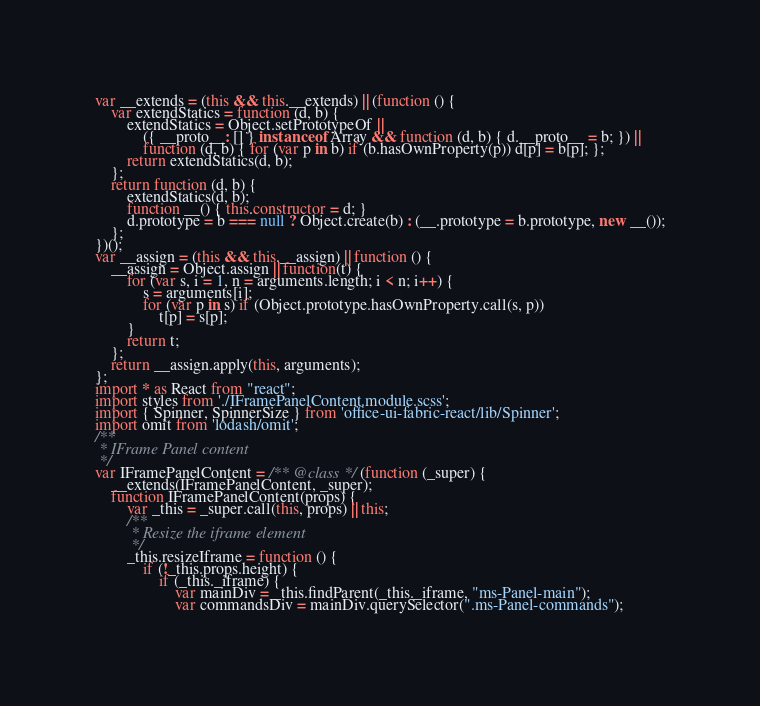<code> <loc_0><loc_0><loc_500><loc_500><_JavaScript_>var __extends = (this && this.__extends) || (function () {
    var extendStatics = function (d, b) {
        extendStatics = Object.setPrototypeOf ||
            ({ __proto__: [] } instanceof Array && function (d, b) { d.__proto__ = b; }) ||
            function (d, b) { for (var p in b) if (b.hasOwnProperty(p)) d[p] = b[p]; };
        return extendStatics(d, b);
    };
    return function (d, b) {
        extendStatics(d, b);
        function __() { this.constructor = d; }
        d.prototype = b === null ? Object.create(b) : (__.prototype = b.prototype, new __());
    };
})();
var __assign = (this && this.__assign) || function () {
    __assign = Object.assign || function(t) {
        for (var s, i = 1, n = arguments.length; i < n; i++) {
            s = arguments[i];
            for (var p in s) if (Object.prototype.hasOwnProperty.call(s, p))
                t[p] = s[p];
        }
        return t;
    };
    return __assign.apply(this, arguments);
};
import * as React from "react";
import styles from './IFramePanelContent.module.scss';
import { Spinner, SpinnerSize } from 'office-ui-fabric-react/lib/Spinner';
import omit from 'lodash/omit';
/**
 * IFrame Panel content
 */
var IFramePanelContent = /** @class */ (function (_super) {
    __extends(IFramePanelContent, _super);
    function IFramePanelContent(props) {
        var _this = _super.call(this, props) || this;
        /**
         * Resize the iframe element
         */
        _this.resizeIframe = function () {
            if (!_this.props.height) {
                if (_this._iframe) {
                    var mainDiv = _this.findParent(_this._iframe, "ms-Panel-main");
                    var commandsDiv = mainDiv.querySelector(".ms-Panel-commands");</code> 